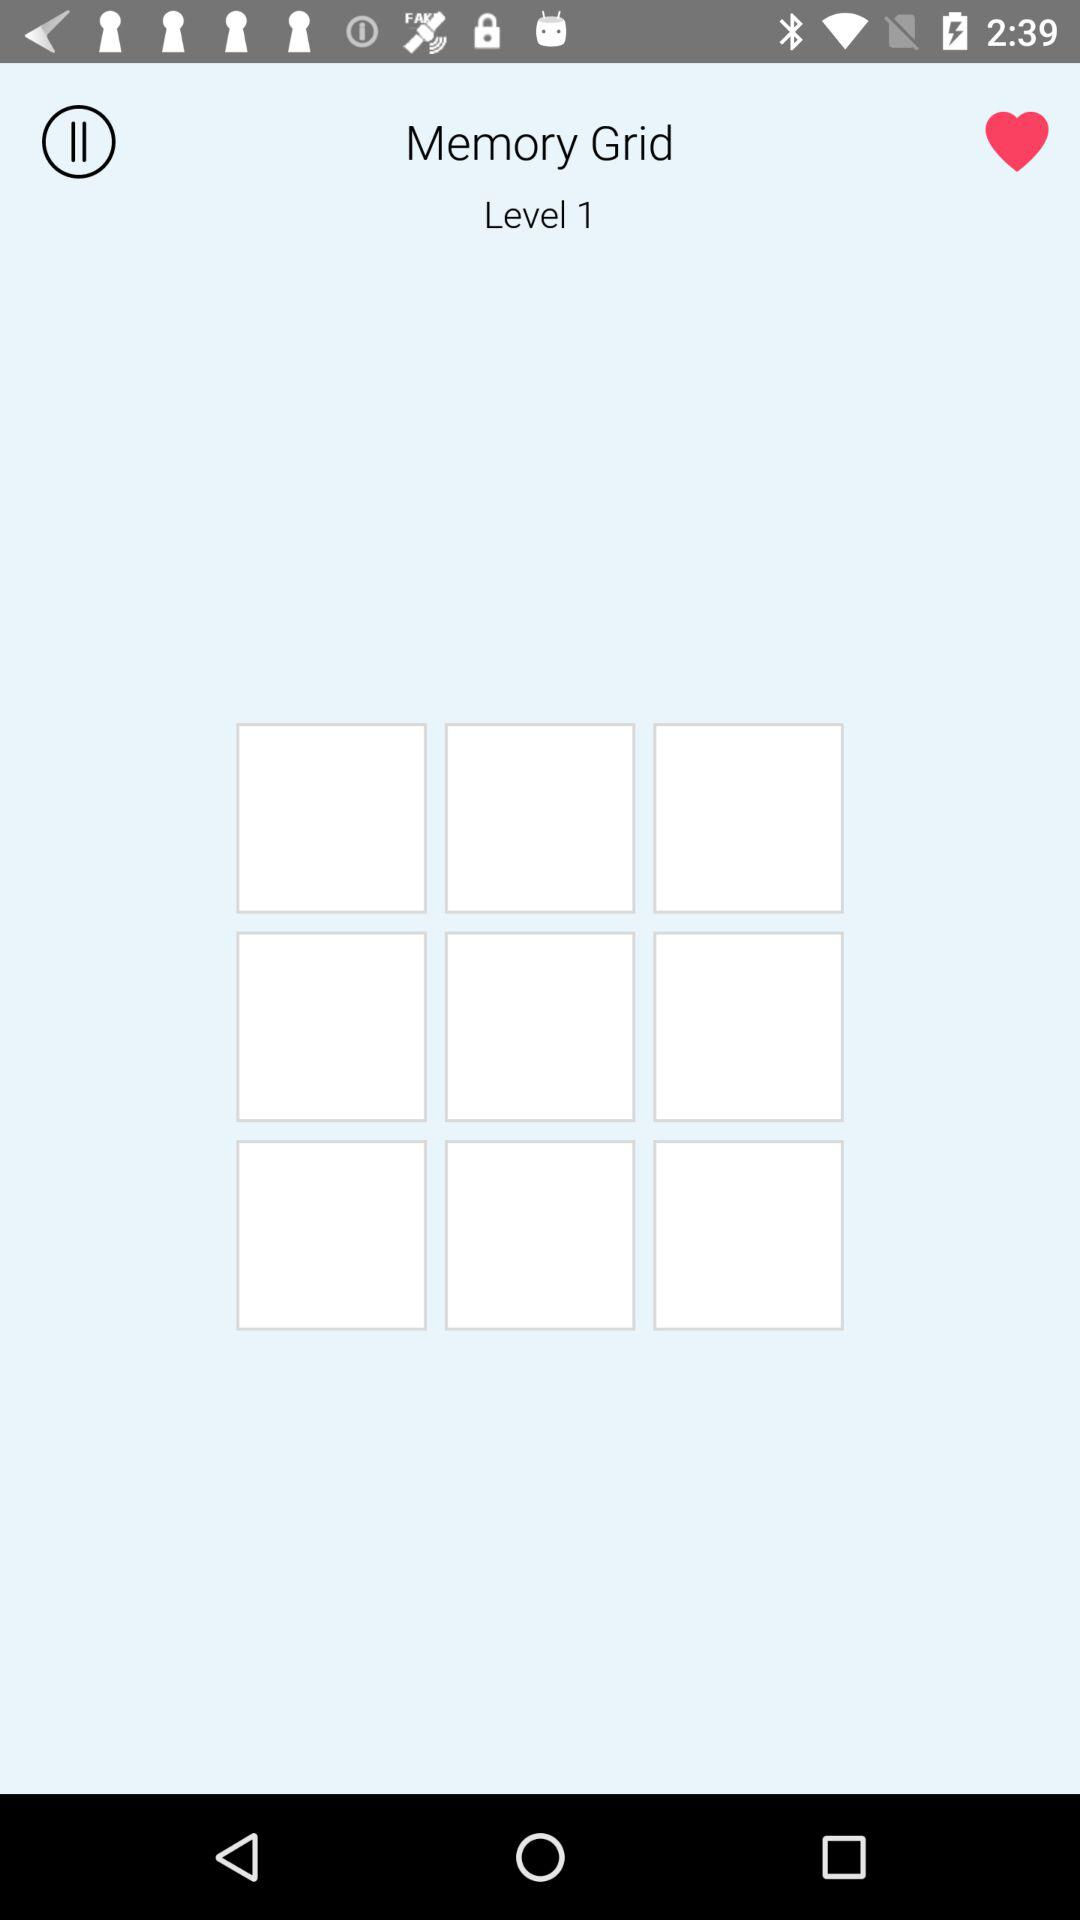How long do I have to complete this?
When the provided information is insufficient, respond with <no answer>. <no answer> 